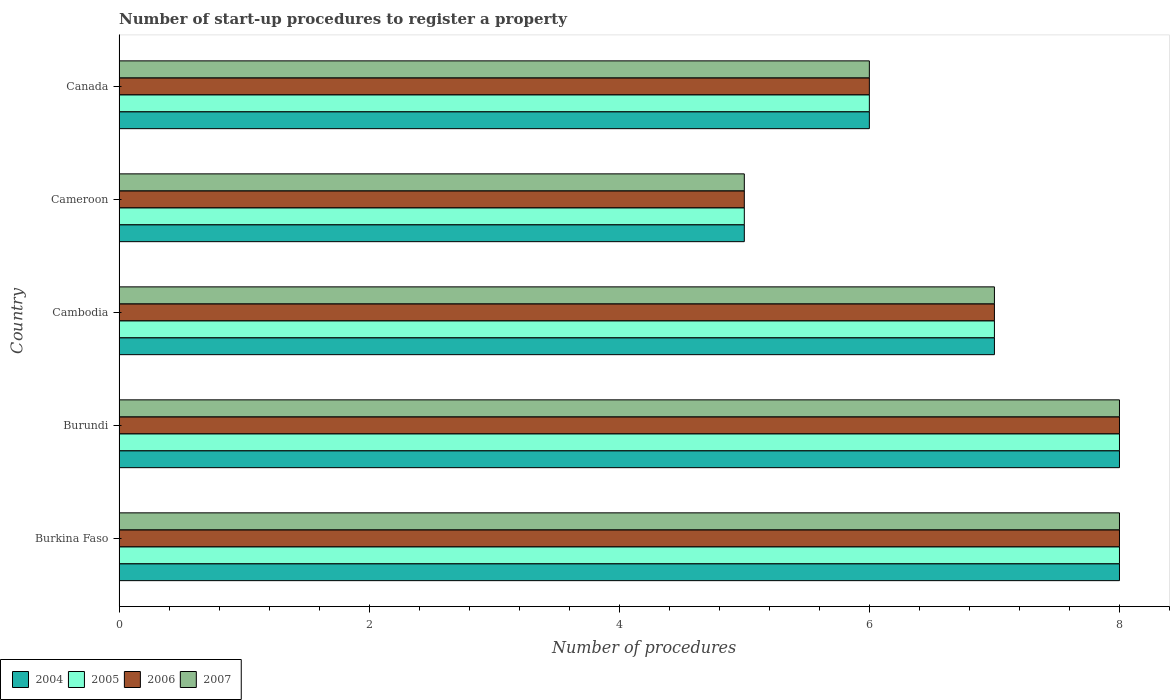How many different coloured bars are there?
Your answer should be compact. 4. Are the number of bars per tick equal to the number of legend labels?
Provide a succinct answer. Yes. Are the number of bars on each tick of the Y-axis equal?
Provide a succinct answer. Yes. How many bars are there on the 1st tick from the bottom?
Offer a terse response. 4. What is the label of the 3rd group of bars from the top?
Keep it short and to the point. Cambodia. In how many cases, is the number of bars for a given country not equal to the number of legend labels?
Offer a very short reply. 0. Across all countries, what is the minimum number of procedures required to register a property in 2004?
Make the answer very short. 5. In which country was the number of procedures required to register a property in 2005 maximum?
Give a very brief answer. Burkina Faso. In which country was the number of procedures required to register a property in 2005 minimum?
Keep it short and to the point. Cameroon. What is the difference between the number of procedures required to register a property in 2007 in Burkina Faso and that in Cameroon?
Ensure brevity in your answer.  3. What is the difference between the number of procedures required to register a property in 2004 in Cambodia and the number of procedures required to register a property in 2005 in Canada?
Offer a terse response. 1. What is the average number of procedures required to register a property in 2007 per country?
Make the answer very short. 6.8. What is the difference between the number of procedures required to register a property in 2006 and number of procedures required to register a property in 2007 in Cameroon?
Make the answer very short. 0. In how many countries, is the number of procedures required to register a property in 2006 greater than 3.6 ?
Provide a short and direct response. 5. What is the ratio of the number of procedures required to register a property in 2004 in Burundi to that in Cameroon?
Keep it short and to the point. 1.6. Is it the case that in every country, the sum of the number of procedures required to register a property in 2006 and number of procedures required to register a property in 2007 is greater than the sum of number of procedures required to register a property in 2004 and number of procedures required to register a property in 2005?
Your answer should be very brief. No. Is it the case that in every country, the sum of the number of procedures required to register a property in 2004 and number of procedures required to register a property in 2005 is greater than the number of procedures required to register a property in 2006?
Provide a short and direct response. Yes. What is the difference between two consecutive major ticks on the X-axis?
Your response must be concise. 2. Are the values on the major ticks of X-axis written in scientific E-notation?
Your response must be concise. No. Does the graph contain any zero values?
Your answer should be very brief. No. Does the graph contain grids?
Make the answer very short. No. Where does the legend appear in the graph?
Make the answer very short. Bottom left. How many legend labels are there?
Provide a short and direct response. 4. How are the legend labels stacked?
Offer a terse response. Horizontal. What is the title of the graph?
Your answer should be very brief. Number of start-up procedures to register a property. Does "1990" appear as one of the legend labels in the graph?
Offer a terse response. No. What is the label or title of the X-axis?
Offer a terse response. Number of procedures. What is the label or title of the Y-axis?
Ensure brevity in your answer.  Country. What is the Number of procedures of 2006 in Burkina Faso?
Offer a very short reply. 8. What is the Number of procedures of 2007 in Burkina Faso?
Your answer should be compact. 8. What is the Number of procedures in 2006 in Burundi?
Provide a short and direct response. 8. What is the Number of procedures in 2004 in Cambodia?
Ensure brevity in your answer.  7. What is the Number of procedures of 2006 in Cambodia?
Your answer should be compact. 7. What is the Number of procedures in 2007 in Cambodia?
Your answer should be very brief. 7. What is the Number of procedures in 2004 in Cameroon?
Your answer should be very brief. 5. What is the Number of procedures in 2006 in Cameroon?
Offer a very short reply. 5. What is the Number of procedures of 2007 in Cameroon?
Your response must be concise. 5. What is the Number of procedures in 2004 in Canada?
Your response must be concise. 6. What is the Number of procedures in 2007 in Canada?
Offer a terse response. 6. Across all countries, what is the maximum Number of procedures of 2006?
Your response must be concise. 8. Across all countries, what is the minimum Number of procedures of 2005?
Your answer should be compact. 5. What is the total Number of procedures of 2004 in the graph?
Provide a succinct answer. 34. What is the total Number of procedures of 2005 in the graph?
Provide a succinct answer. 34. What is the total Number of procedures of 2006 in the graph?
Offer a very short reply. 34. What is the total Number of procedures in 2007 in the graph?
Your answer should be compact. 34. What is the difference between the Number of procedures in 2004 in Burkina Faso and that in Burundi?
Ensure brevity in your answer.  0. What is the difference between the Number of procedures in 2005 in Burkina Faso and that in Burundi?
Keep it short and to the point. 0. What is the difference between the Number of procedures of 2005 in Burkina Faso and that in Cambodia?
Provide a short and direct response. 1. What is the difference between the Number of procedures of 2007 in Burkina Faso and that in Cambodia?
Give a very brief answer. 1. What is the difference between the Number of procedures of 2004 in Burkina Faso and that in Cameroon?
Ensure brevity in your answer.  3. What is the difference between the Number of procedures of 2005 in Burkina Faso and that in Cameroon?
Your answer should be compact. 3. What is the difference between the Number of procedures in 2007 in Burkina Faso and that in Cameroon?
Your answer should be very brief. 3. What is the difference between the Number of procedures in 2004 in Burkina Faso and that in Canada?
Provide a short and direct response. 2. What is the difference between the Number of procedures of 2005 in Burkina Faso and that in Canada?
Provide a short and direct response. 2. What is the difference between the Number of procedures of 2006 in Burkina Faso and that in Canada?
Your answer should be very brief. 2. What is the difference between the Number of procedures of 2005 in Burundi and that in Cambodia?
Keep it short and to the point. 1. What is the difference between the Number of procedures in 2006 in Burundi and that in Cambodia?
Keep it short and to the point. 1. What is the difference between the Number of procedures in 2006 in Burundi and that in Cameroon?
Give a very brief answer. 3. What is the difference between the Number of procedures in 2004 in Burundi and that in Canada?
Provide a short and direct response. 2. What is the difference between the Number of procedures in 2006 in Burundi and that in Canada?
Offer a very short reply. 2. What is the difference between the Number of procedures in 2007 in Burundi and that in Canada?
Provide a succinct answer. 2. What is the difference between the Number of procedures in 2004 in Cambodia and that in Cameroon?
Make the answer very short. 2. What is the difference between the Number of procedures in 2005 in Cambodia and that in Cameroon?
Your answer should be compact. 2. What is the difference between the Number of procedures in 2006 in Cambodia and that in Cameroon?
Ensure brevity in your answer.  2. What is the difference between the Number of procedures in 2004 in Cambodia and that in Canada?
Provide a succinct answer. 1. What is the difference between the Number of procedures of 2005 in Cambodia and that in Canada?
Provide a short and direct response. 1. What is the difference between the Number of procedures in 2006 in Cambodia and that in Canada?
Provide a short and direct response. 1. What is the difference between the Number of procedures of 2004 in Cameroon and that in Canada?
Make the answer very short. -1. What is the difference between the Number of procedures in 2005 in Cameroon and that in Canada?
Give a very brief answer. -1. What is the difference between the Number of procedures of 2004 in Burkina Faso and the Number of procedures of 2005 in Burundi?
Your answer should be compact. 0. What is the difference between the Number of procedures in 2004 in Burkina Faso and the Number of procedures in 2006 in Burundi?
Provide a short and direct response. 0. What is the difference between the Number of procedures of 2005 in Burkina Faso and the Number of procedures of 2006 in Burundi?
Your answer should be compact. 0. What is the difference between the Number of procedures of 2006 in Burkina Faso and the Number of procedures of 2007 in Burundi?
Ensure brevity in your answer.  0. What is the difference between the Number of procedures in 2004 in Burkina Faso and the Number of procedures in 2005 in Cambodia?
Give a very brief answer. 1. What is the difference between the Number of procedures in 2004 in Burkina Faso and the Number of procedures in 2006 in Cambodia?
Offer a very short reply. 1. What is the difference between the Number of procedures in 2004 in Burkina Faso and the Number of procedures in 2007 in Cambodia?
Offer a terse response. 1. What is the difference between the Number of procedures of 2005 in Burkina Faso and the Number of procedures of 2006 in Cambodia?
Your answer should be very brief. 1. What is the difference between the Number of procedures in 2004 in Burkina Faso and the Number of procedures in 2005 in Cameroon?
Make the answer very short. 3. What is the difference between the Number of procedures of 2004 in Burkina Faso and the Number of procedures of 2006 in Cameroon?
Ensure brevity in your answer.  3. What is the difference between the Number of procedures of 2005 in Burkina Faso and the Number of procedures of 2006 in Cameroon?
Keep it short and to the point. 3. What is the difference between the Number of procedures of 2005 in Burkina Faso and the Number of procedures of 2007 in Cameroon?
Your response must be concise. 3. What is the difference between the Number of procedures in 2004 in Burkina Faso and the Number of procedures in 2006 in Canada?
Your answer should be very brief. 2. What is the difference between the Number of procedures of 2004 in Burkina Faso and the Number of procedures of 2007 in Canada?
Make the answer very short. 2. What is the difference between the Number of procedures of 2005 in Burkina Faso and the Number of procedures of 2006 in Canada?
Provide a short and direct response. 2. What is the difference between the Number of procedures in 2005 in Burkina Faso and the Number of procedures in 2007 in Canada?
Give a very brief answer. 2. What is the difference between the Number of procedures of 2004 in Burundi and the Number of procedures of 2006 in Cambodia?
Offer a terse response. 1. What is the difference between the Number of procedures of 2004 in Burundi and the Number of procedures of 2007 in Cambodia?
Ensure brevity in your answer.  1. What is the difference between the Number of procedures of 2006 in Burundi and the Number of procedures of 2007 in Cambodia?
Provide a short and direct response. 1. What is the difference between the Number of procedures in 2004 in Burundi and the Number of procedures in 2006 in Cameroon?
Make the answer very short. 3. What is the difference between the Number of procedures in 2004 in Burundi and the Number of procedures in 2007 in Cameroon?
Give a very brief answer. 3. What is the difference between the Number of procedures of 2005 in Burundi and the Number of procedures of 2006 in Cameroon?
Keep it short and to the point. 3. What is the difference between the Number of procedures in 2005 in Burundi and the Number of procedures in 2007 in Cameroon?
Your answer should be compact. 3. What is the difference between the Number of procedures of 2004 in Burundi and the Number of procedures of 2005 in Canada?
Offer a terse response. 2. What is the difference between the Number of procedures of 2004 in Cambodia and the Number of procedures of 2006 in Cameroon?
Offer a terse response. 2. What is the difference between the Number of procedures of 2005 in Cambodia and the Number of procedures of 2006 in Cameroon?
Ensure brevity in your answer.  2. What is the difference between the Number of procedures in 2005 in Cameroon and the Number of procedures in 2006 in Canada?
Provide a succinct answer. -1. What is the difference between the Number of procedures in 2005 in Cameroon and the Number of procedures in 2007 in Canada?
Offer a very short reply. -1. What is the average Number of procedures in 2004 per country?
Keep it short and to the point. 6.8. What is the average Number of procedures of 2005 per country?
Offer a very short reply. 6.8. What is the average Number of procedures of 2007 per country?
Provide a succinct answer. 6.8. What is the difference between the Number of procedures in 2004 and Number of procedures in 2005 in Burkina Faso?
Your answer should be very brief. 0. What is the difference between the Number of procedures of 2004 and Number of procedures of 2006 in Burkina Faso?
Keep it short and to the point. 0. What is the difference between the Number of procedures of 2005 and Number of procedures of 2006 in Burkina Faso?
Give a very brief answer. 0. What is the difference between the Number of procedures in 2006 and Number of procedures in 2007 in Burkina Faso?
Your response must be concise. 0. What is the difference between the Number of procedures of 2006 and Number of procedures of 2007 in Burundi?
Provide a succinct answer. 0. What is the difference between the Number of procedures of 2004 and Number of procedures of 2005 in Cambodia?
Keep it short and to the point. 0. What is the difference between the Number of procedures in 2004 and Number of procedures in 2006 in Cambodia?
Offer a terse response. 0. What is the difference between the Number of procedures of 2005 and Number of procedures of 2006 in Cambodia?
Your answer should be very brief. 0. What is the difference between the Number of procedures in 2006 and Number of procedures in 2007 in Cambodia?
Your response must be concise. 0. What is the difference between the Number of procedures of 2004 and Number of procedures of 2005 in Cameroon?
Keep it short and to the point. 0. What is the difference between the Number of procedures in 2005 and Number of procedures in 2006 in Cameroon?
Offer a terse response. 0. What is the difference between the Number of procedures in 2005 and Number of procedures in 2007 in Cameroon?
Offer a very short reply. 0. What is the difference between the Number of procedures of 2004 and Number of procedures of 2005 in Canada?
Offer a very short reply. 0. What is the difference between the Number of procedures in 2004 and Number of procedures in 2006 in Canada?
Make the answer very short. 0. What is the ratio of the Number of procedures in 2005 in Burkina Faso to that in Burundi?
Give a very brief answer. 1. What is the ratio of the Number of procedures of 2006 in Burkina Faso to that in Burundi?
Make the answer very short. 1. What is the ratio of the Number of procedures in 2004 in Burkina Faso to that in Cambodia?
Offer a terse response. 1.14. What is the ratio of the Number of procedures of 2005 in Burkina Faso to that in Cambodia?
Ensure brevity in your answer.  1.14. What is the ratio of the Number of procedures in 2007 in Burkina Faso to that in Cambodia?
Give a very brief answer. 1.14. What is the ratio of the Number of procedures in 2004 in Burkina Faso to that in Cameroon?
Offer a very short reply. 1.6. What is the ratio of the Number of procedures of 2005 in Burkina Faso to that in Cameroon?
Your answer should be very brief. 1.6. What is the ratio of the Number of procedures in 2006 in Burkina Faso to that in Cameroon?
Your answer should be very brief. 1.6. What is the ratio of the Number of procedures of 2004 in Burkina Faso to that in Canada?
Offer a very short reply. 1.33. What is the ratio of the Number of procedures in 2005 in Burkina Faso to that in Canada?
Provide a short and direct response. 1.33. What is the ratio of the Number of procedures of 2006 in Burkina Faso to that in Canada?
Provide a short and direct response. 1.33. What is the ratio of the Number of procedures in 2004 in Burundi to that in Cambodia?
Give a very brief answer. 1.14. What is the ratio of the Number of procedures of 2007 in Burundi to that in Cambodia?
Your answer should be compact. 1.14. What is the ratio of the Number of procedures of 2004 in Burundi to that in Cameroon?
Provide a short and direct response. 1.6. What is the ratio of the Number of procedures of 2005 in Burundi to that in Cameroon?
Give a very brief answer. 1.6. What is the ratio of the Number of procedures of 2006 in Burundi to that in Cameroon?
Your response must be concise. 1.6. What is the ratio of the Number of procedures in 2005 in Burundi to that in Canada?
Provide a short and direct response. 1.33. What is the ratio of the Number of procedures of 2005 in Cambodia to that in Cameroon?
Make the answer very short. 1.4. What is the ratio of the Number of procedures in 2006 in Cambodia to that in Cameroon?
Offer a very short reply. 1.4. What is the ratio of the Number of procedures in 2007 in Cambodia to that in Cameroon?
Keep it short and to the point. 1.4. What is the ratio of the Number of procedures of 2007 in Cambodia to that in Canada?
Give a very brief answer. 1.17. What is the ratio of the Number of procedures of 2004 in Cameroon to that in Canada?
Provide a short and direct response. 0.83. What is the ratio of the Number of procedures in 2005 in Cameroon to that in Canada?
Offer a very short reply. 0.83. What is the ratio of the Number of procedures in 2007 in Cameroon to that in Canada?
Give a very brief answer. 0.83. What is the difference between the highest and the second highest Number of procedures of 2004?
Provide a succinct answer. 0. What is the difference between the highest and the second highest Number of procedures of 2007?
Provide a succinct answer. 0. What is the difference between the highest and the lowest Number of procedures in 2004?
Keep it short and to the point. 3. What is the difference between the highest and the lowest Number of procedures in 2007?
Your answer should be compact. 3. 